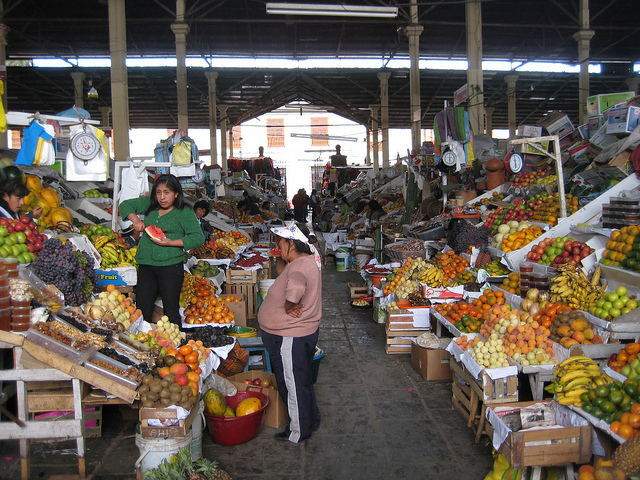Can you infer what time of day it might be in the market? Based on the lighting and the shadows visible in the image, it seems to be daytime. The market is active but not overly crowded, which might suggest it is either morning or early afternoon, typical times for such markets to be open and busy. 